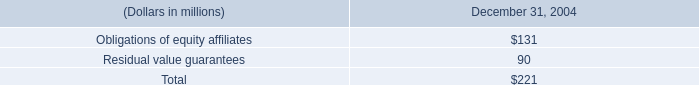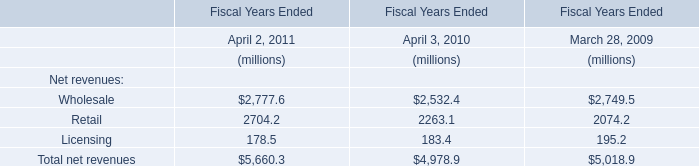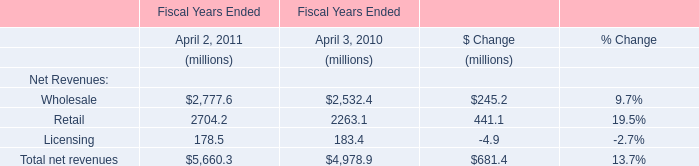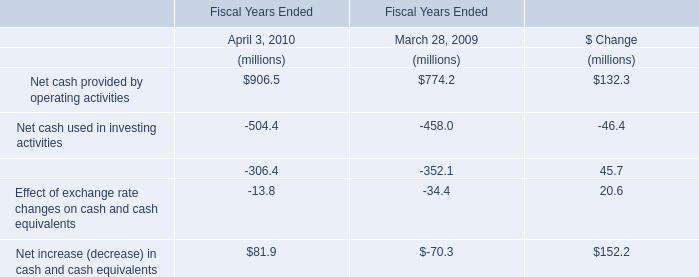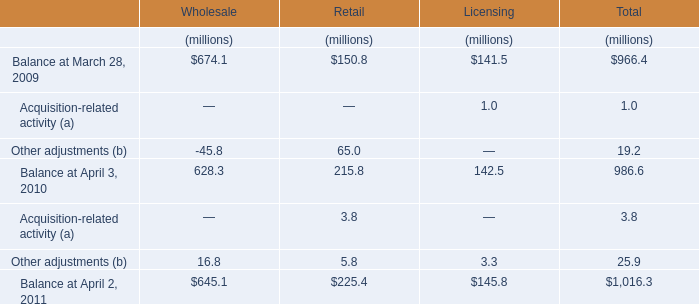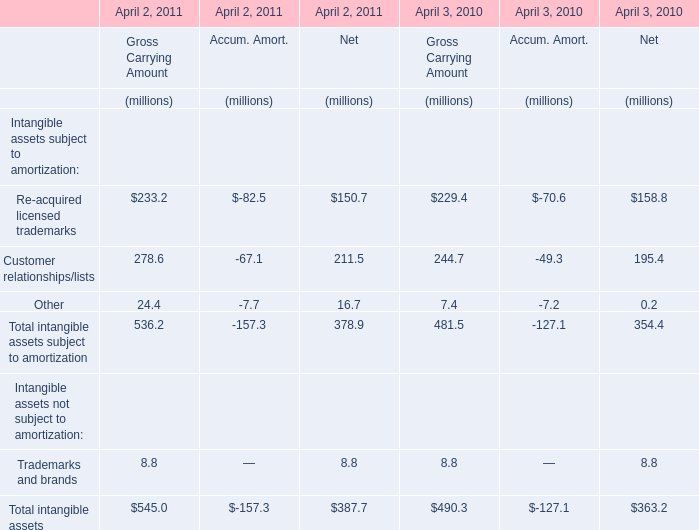What's the 40% of total elements for Gross Carrying Amount in 2010? (in million) 
Computations: (490.3 * 0.4)
Answer: 196.12. 